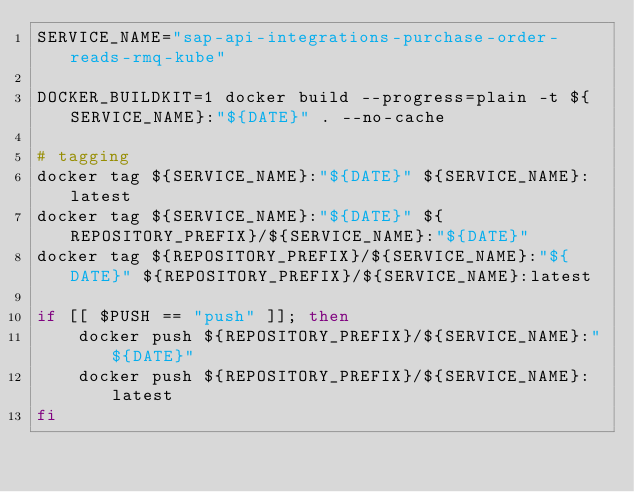<code> <loc_0><loc_0><loc_500><loc_500><_Bash_>SERVICE_NAME="sap-api-integrations-purchase-order-reads-rmq-kube"

DOCKER_BUILDKIT=1 docker build --progress=plain -t ${SERVICE_NAME}:"${DATE}" . --no-cache

# tagging
docker tag ${SERVICE_NAME}:"${DATE}" ${SERVICE_NAME}:latest
docker tag ${SERVICE_NAME}:"${DATE}" ${REPOSITORY_PREFIX}/${SERVICE_NAME}:"${DATE}"
docker tag ${REPOSITORY_PREFIX}/${SERVICE_NAME}:"${DATE}" ${REPOSITORY_PREFIX}/${SERVICE_NAME}:latest

if [[ $PUSH == "push" ]]; then
    docker push ${REPOSITORY_PREFIX}/${SERVICE_NAME}:"${DATE}"
    docker push ${REPOSITORY_PREFIX}/${SERVICE_NAME}:latest
fi
</code> 